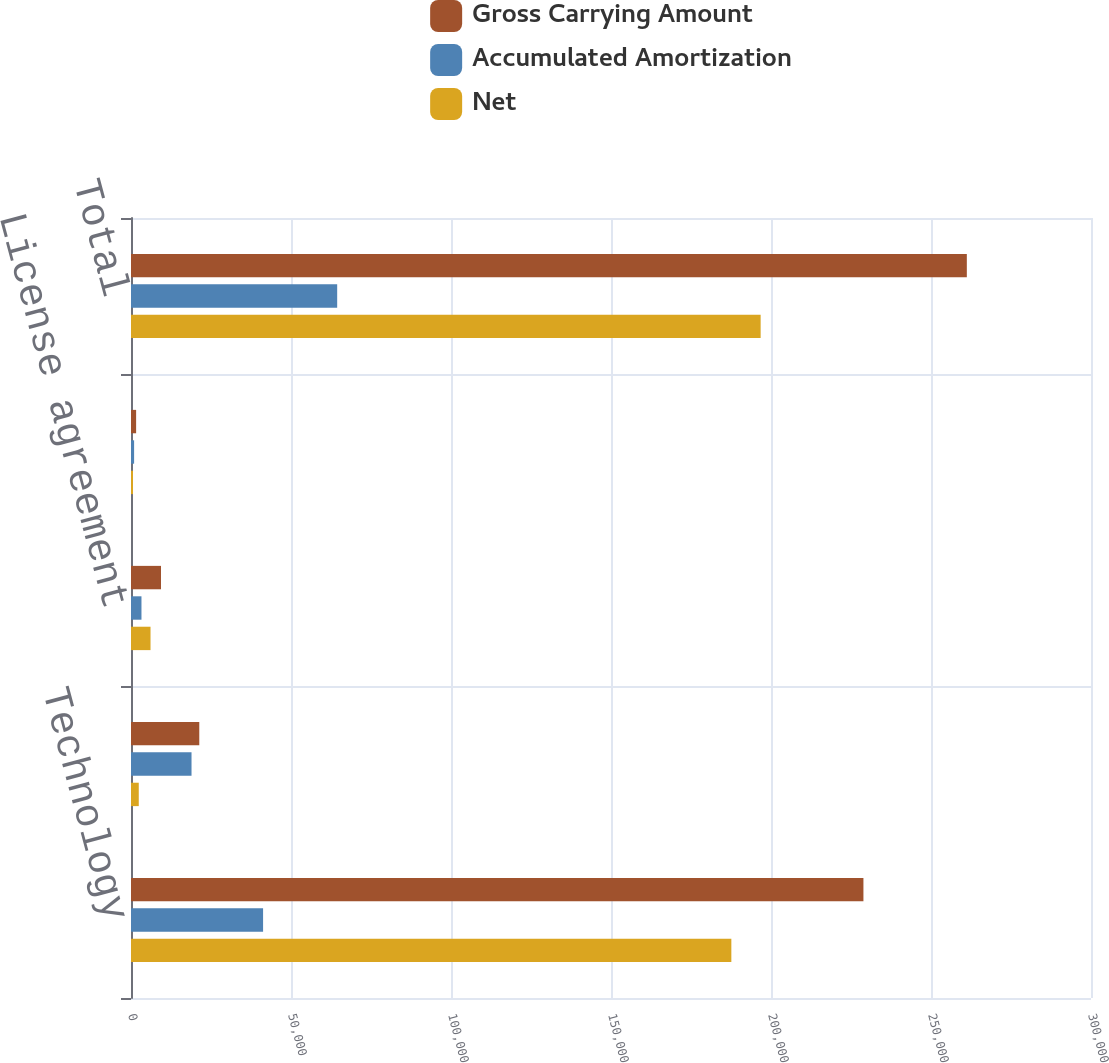Convert chart. <chart><loc_0><loc_0><loc_500><loc_500><stacked_bar_chart><ecel><fcel>Technology<fcel>Order backlog<fcel>License agreement<fcel>Other<fcel>Total<nl><fcel>Gross Carrying Amount<fcel>228884<fcel>21340<fcel>9373<fcel>1600<fcel>261197<nl><fcel>Accumulated Amortization<fcel>41276<fcel>18914<fcel>3272<fcel>970<fcel>64432<nl><fcel>Net<fcel>187608<fcel>2426<fcel>6101<fcel>630<fcel>196765<nl></chart> 